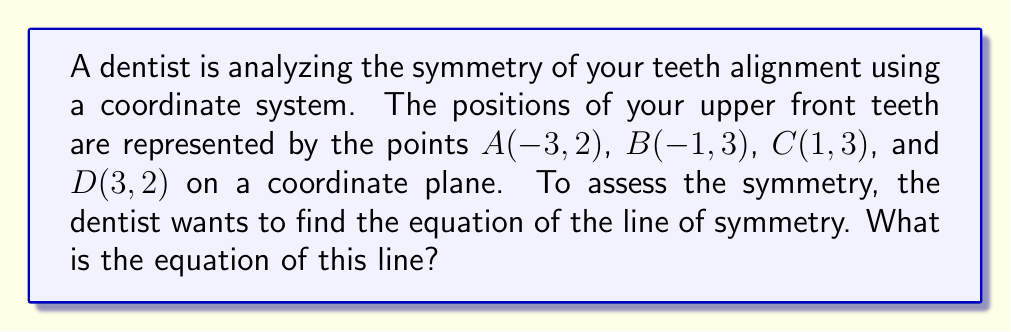Help me with this question. Let's approach this step-by-step:

1) In a perfectly symmetrical alignment, the line of symmetry would pass through the midpoint of the central pair of teeth (points B and C) and be perpendicular to the line connecting them.

2) First, let's find the midpoint of BC:
   $M_x = \frac{x_B + x_C}{2} = \frac{-1 + 1}{2} = 0$
   $M_y = \frac{y_B + y_C}{2} = \frac{3 + 3}{2} = 3$
   So, the midpoint M is $(0, 3)$

3) The slope of BC is:
   $m_{BC} = \frac{y_C - y_B}{x_C - x_B} = \frac{3 - 3}{1 - (-1)} = 0$

4) The line of symmetry must be perpendicular to BC. For perpendicular lines, the product of their slopes is -1. So, if the slope of BC is 0, the slope of the line of symmetry must be undefined (vertical line).

5) The equation of a vertical line is of the form $x = a$, where $a$ is the x-coordinate of any point on the line.

6) We know that this line passes through the midpoint M(0, 3), so $a = 0$.

Therefore, the equation of the line of symmetry is $x = 0$.
Answer: $x = 0$ 